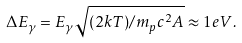<formula> <loc_0><loc_0><loc_500><loc_500>\Delta E _ { \gamma } = E _ { \gamma } \sqrt { ( 2 k T ) / m _ { p } c ^ { 2 } A } \approx 1 e V .</formula> 